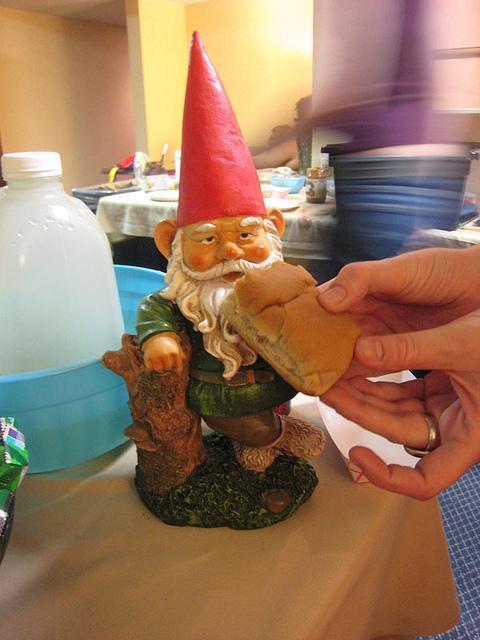How many bowls are in the photo?
Give a very brief answer. 3. How many spoons are there?
Give a very brief answer. 0. 